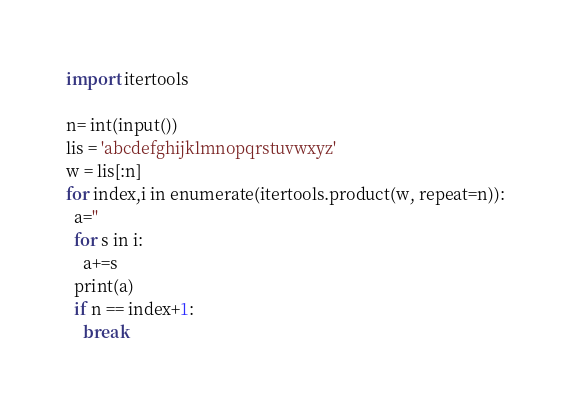Convert code to text. <code><loc_0><loc_0><loc_500><loc_500><_Python_>import itertools

n= int(input())
lis = 'abcdefghijklmnopqrstuvwxyz'
w = lis[:n]
for index,i in enumerate(itertools.product(w, repeat=n)):
  a=''
  for s in i:
    a+=s
  print(a)
  if n == index+1:
    break</code> 